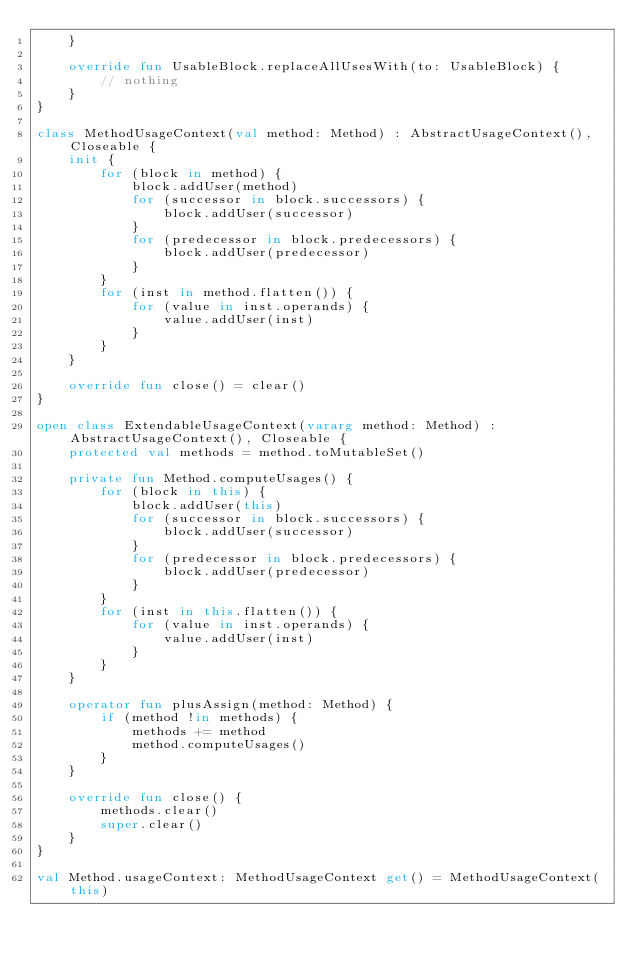Convert code to text. <code><loc_0><loc_0><loc_500><loc_500><_Kotlin_>    }

    override fun UsableBlock.replaceAllUsesWith(to: UsableBlock) {
        // nothing
    }
}

class MethodUsageContext(val method: Method) : AbstractUsageContext(), Closeable {
    init {
        for (block in method) {
            block.addUser(method)
            for (successor in block.successors) {
                block.addUser(successor)
            }
            for (predecessor in block.predecessors) {
                block.addUser(predecessor)
            }
        }
        for (inst in method.flatten()) {
            for (value in inst.operands) {
                value.addUser(inst)
            }
        }
    }

    override fun close() = clear()
}

open class ExtendableUsageContext(vararg method: Method) : AbstractUsageContext(), Closeable {
    protected val methods = method.toMutableSet()

    private fun Method.computeUsages() {
        for (block in this) {
            block.addUser(this)
            for (successor in block.successors) {
                block.addUser(successor)
            }
            for (predecessor in block.predecessors) {
                block.addUser(predecessor)
            }
        }
        for (inst in this.flatten()) {
            for (value in inst.operands) {
                value.addUser(inst)
            }
        }
    }

    operator fun plusAssign(method: Method) {
        if (method !in methods) {
            methods += method
            method.computeUsages()
        }
    }

    override fun close() {
        methods.clear()
        super.clear()
    }
}

val Method.usageContext: MethodUsageContext get() = MethodUsageContext(this)</code> 